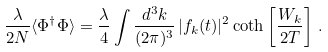<formula> <loc_0><loc_0><loc_500><loc_500>\frac { \lambda } { 2 N } \langle \Phi ^ { \dagger } \Phi \rangle = \frac { \lambda } { 4 } \int \frac { d ^ { 3 } k } { ( 2 \pi ) ^ { 3 } } \, | f _ { k } ( t ) | ^ { 2 } \coth \left [ \frac { W _ { k } } { 2 T } \right ] \, .</formula> 